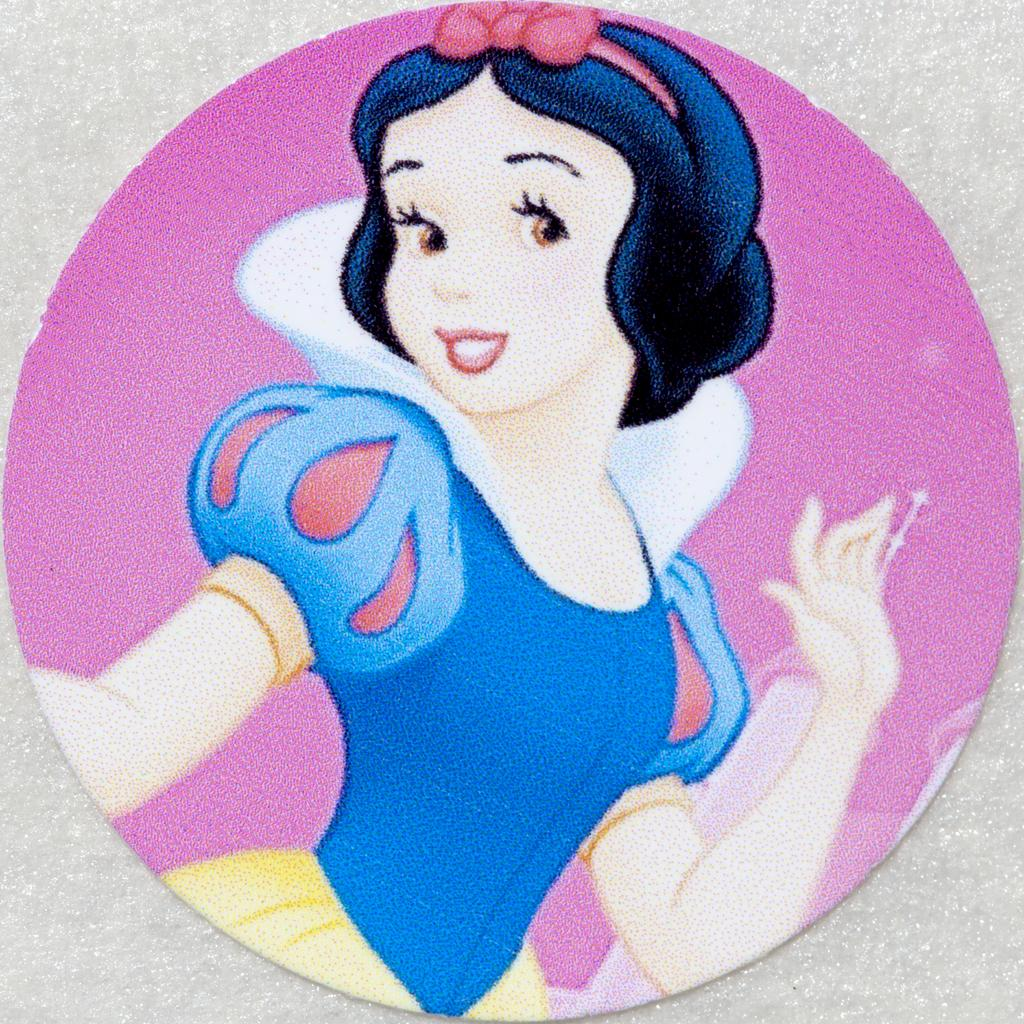What is the main subject of the image? There is a painting in the image. What is depicted in the painting? The painting depicts a girl. What colors are used in the background of the painting? The background of the painting includes pink and white colors. How many eggs are visible in the painting? There are no eggs visible in the painting; it depicts a girl with a pink and white background. What type of tent is set up in the background of the painting? There is no tent present in the painting; it features a girl with a pink and white background. 